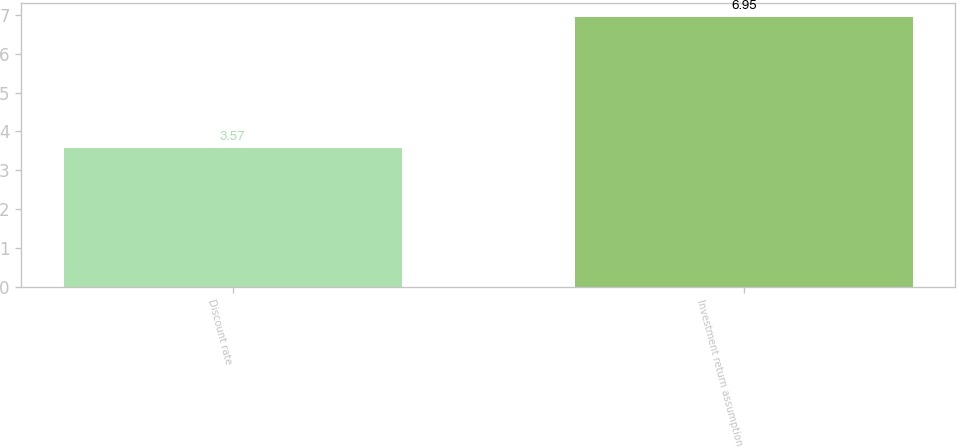Convert chart. <chart><loc_0><loc_0><loc_500><loc_500><bar_chart><fcel>Discount rate<fcel>Investment return assumption<nl><fcel>3.57<fcel>6.95<nl></chart> 